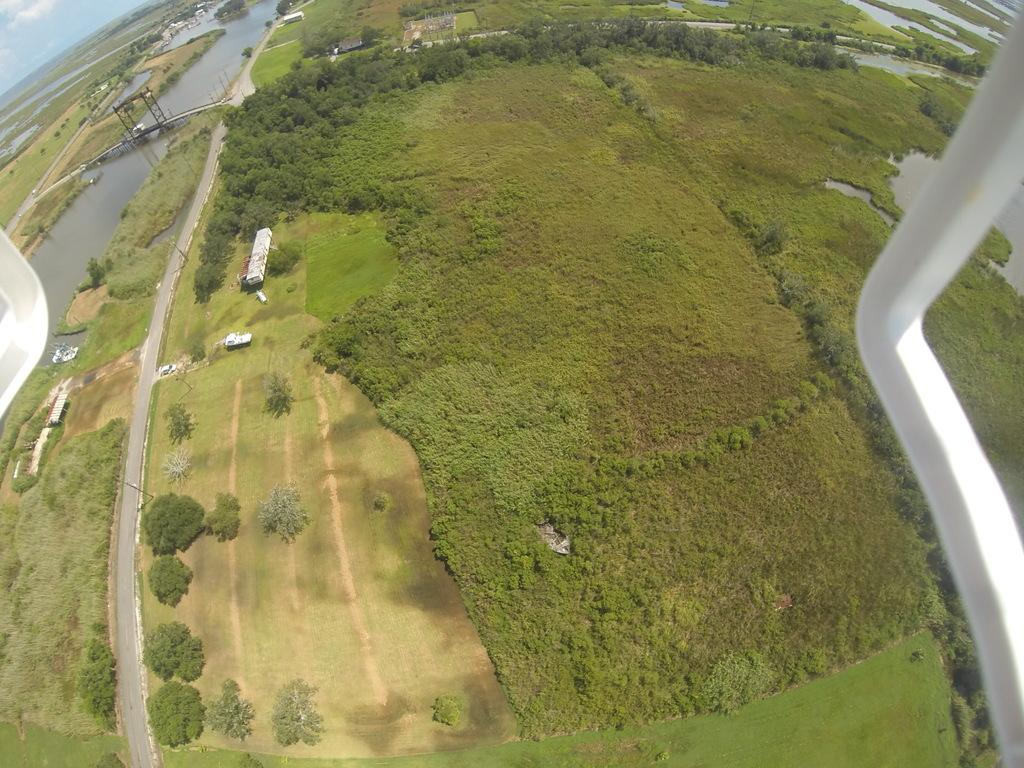What is the perspective of the image? The image provides a view from a height. What can be seen on the right side of the image? There is a water dam on the right side of the image. What can be seen on the left side of the image? There is a bridge on the left side of the image. How many ants can be seen carrying a plate with a cherry on it in the image? There are no ants, plates, or cherries present in the image. 